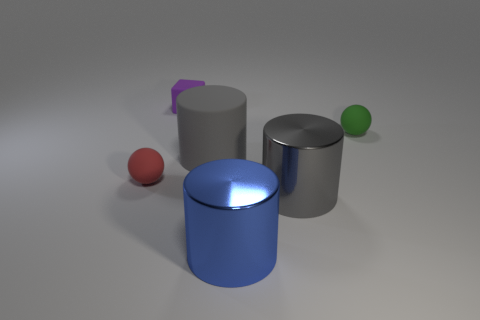Are the large blue cylinder and the small green ball made of the same material?
Your answer should be very brief. No. There is a small matte thing that is left of the green rubber object and behind the red matte thing; what is its color?
Keep it short and to the point. Purple. There is a small matte thing to the right of the small purple block; is it the same color as the rubber cube?
Your response must be concise. No. What is the shape of the purple thing that is the same size as the green matte ball?
Make the answer very short. Cube. How many other things are the same color as the large rubber cylinder?
Your answer should be compact. 1. How many other things are there of the same material as the red ball?
Your answer should be very brief. 3. There is a green object; does it have the same size as the thing in front of the large gray metallic cylinder?
Offer a terse response. No. What color is the big matte thing?
Offer a very short reply. Gray. What shape is the green matte thing right of the matte ball in front of the tiny rubber sphere that is right of the big gray metal thing?
Your answer should be compact. Sphere. What material is the sphere on the left side of the rubber ball right of the purple thing?
Offer a very short reply. Rubber. 